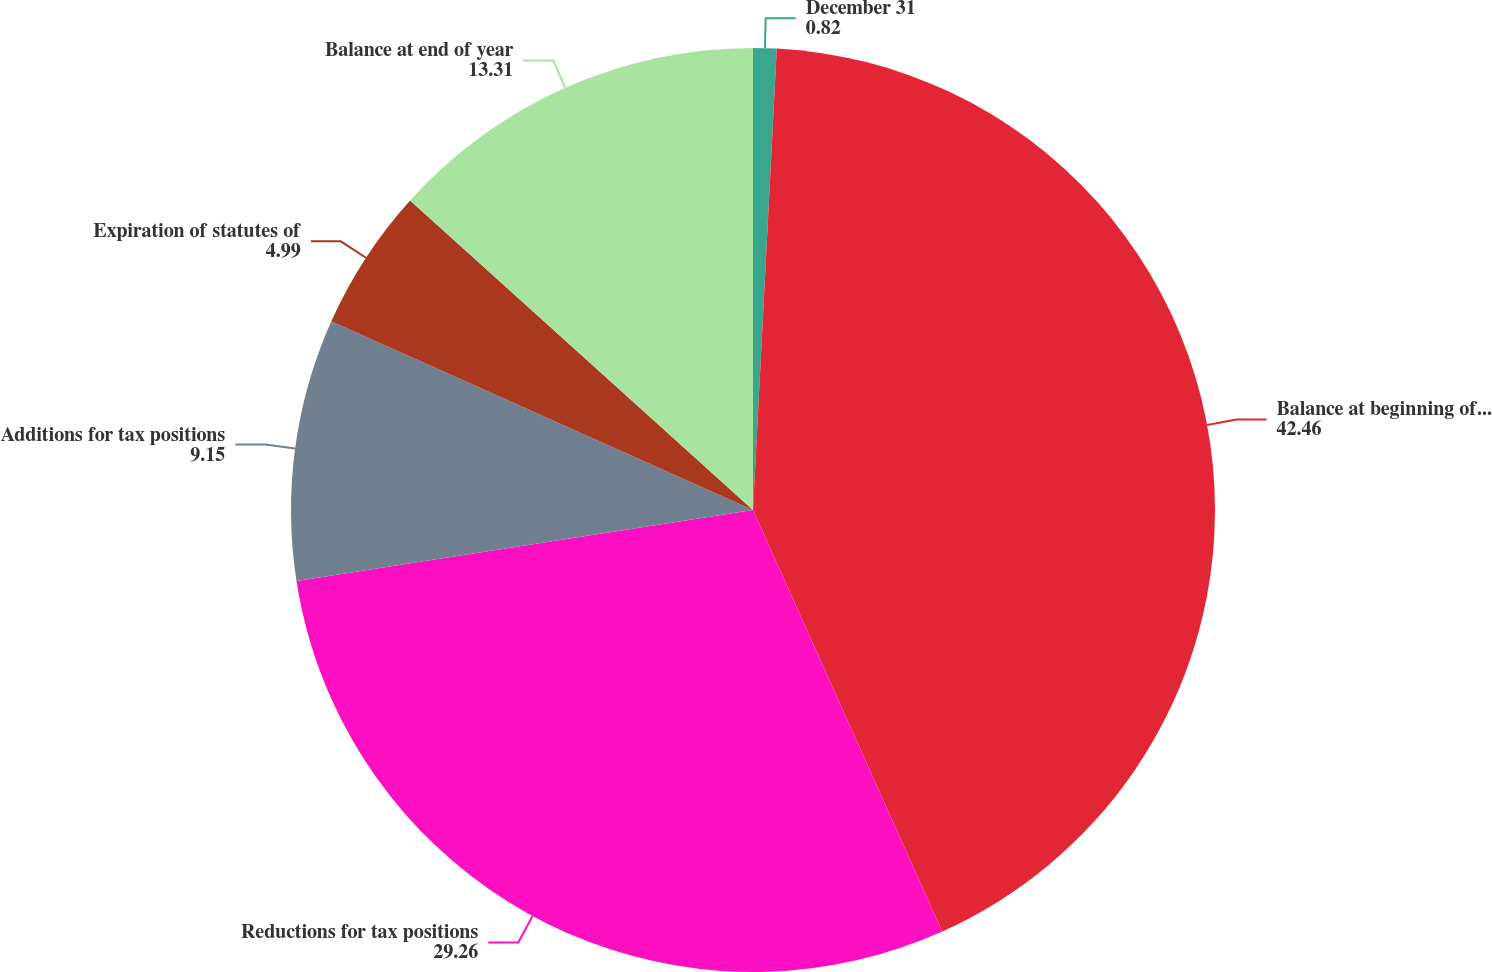<chart> <loc_0><loc_0><loc_500><loc_500><pie_chart><fcel>December 31<fcel>Balance at beginning of year<fcel>Reductions for tax positions<fcel>Additions for tax positions<fcel>Expiration of statutes of<fcel>Balance at end of year<nl><fcel>0.82%<fcel>42.46%<fcel>29.26%<fcel>9.15%<fcel>4.99%<fcel>13.31%<nl></chart> 